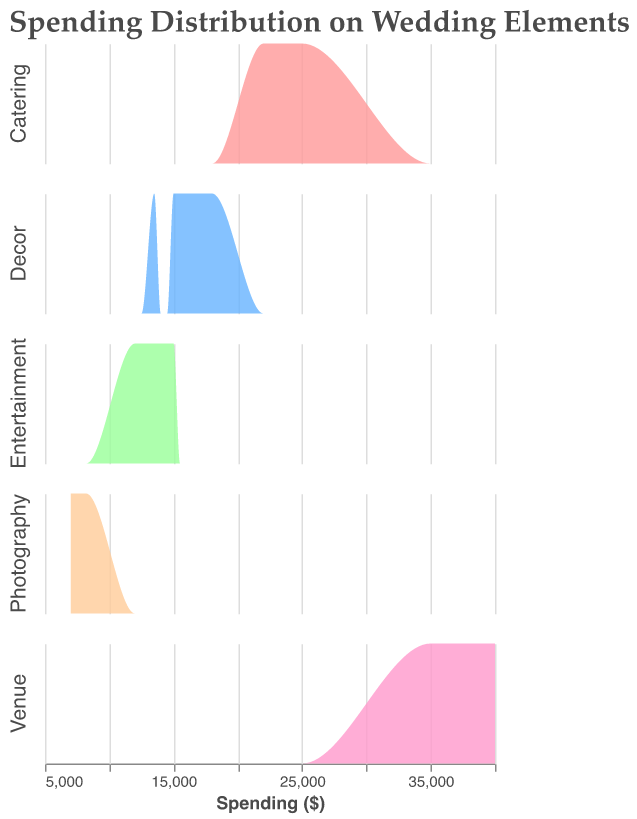What is the title of the figure? The title is usually displayed at the top of the figure and provides a concise description of the main subject.
Answer: Spending Distribution on Wedding Elements What categories are included in the spending distribution analysis? The categories can be identified by examining the row facets, which include labels for each type of wedding element.
Answer: Decor, Catering, Venue, Entertainment, Photography Which category shows the highest spending? By visually comparing the maximum values of the density plots for each category, we can identify which one has the highest spending. Venue has the highest densities at higher spending values (around $40,000).
Answer: Venue What is the spending range for the Catering category? The spending range can be inferred by observing the starting and ending points of the density plots for Catering. The range is between $22,000 and $25,000.
Answer: $22,000 to $25,000 Which category has the lowest average spending? We can infer the lowest average spending by comparing the mean or density peaks of each category. Photography, with densities peaking around $7,000 to $8,200, has the lowest average spending.
Answer: Photography How many data points are represented in the Decor category? Count the number of peaks or individual data points contributing to Decor's density plot. Decor has six data points.
Answer: 6 How does the distribution of spending for Entertainment compare to that of Decor? Compare the density plots of both categories by looking at the distribution patterns and the range of spending. Entertainment spending ranges from $12,000 to $15,000, while Decor spending ranges from $13,500 to $18,000.
Answer: Entertainment ranges: $12,000 to $15,000, Decor ranges: $13,500 to $18,000 Which category has the widest range of spending distribution? Identify the category whose density plot covers the broadest range on the spending axis. Venue, with spending ranging from $35,000 to $40,000, has the widest range.
Answer: Venue What can be inferred from the density plots about the most common spending for Photography? The density plot for Photography shows peaks around $7,000 to $8,200, implying these are the most common spending amounts.
Answer: $7,000 to $8,200 Which color represents the Decor category in the figure? Identify the color used in the density plot legend or the area fill for the Decor category.
Answer: A shade of light red 